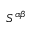<formula> <loc_0><loc_0><loc_500><loc_500>S ^ { \alpha \beta }</formula> 